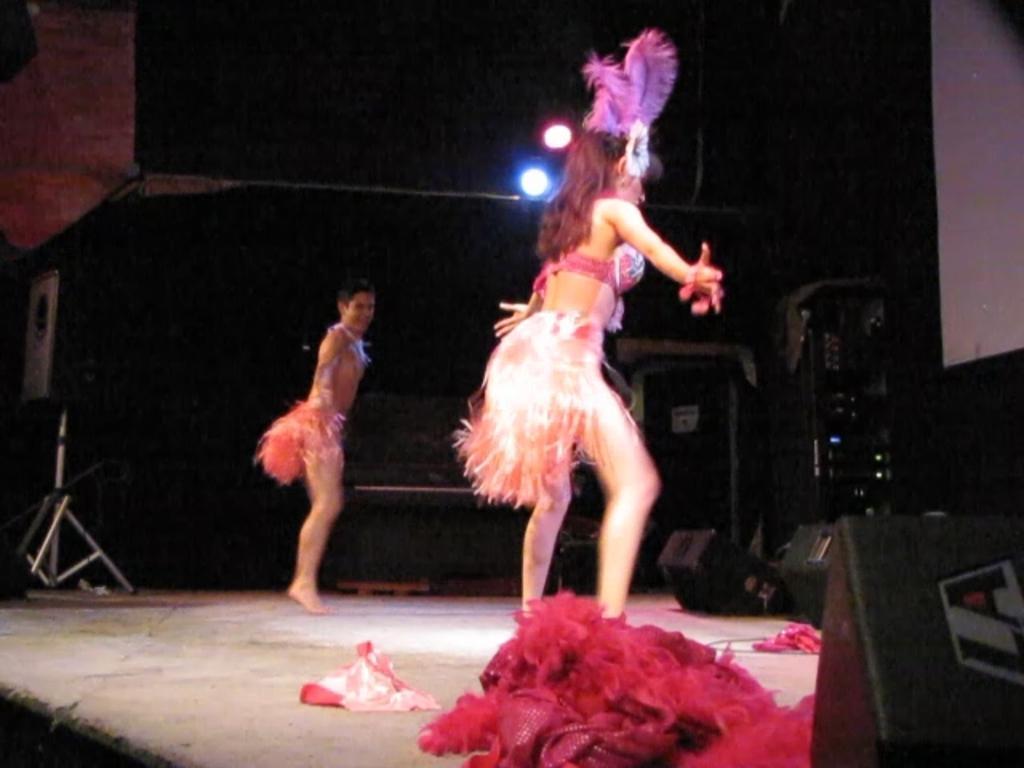In one or two sentences, can you explain what this image depicts? In this image, there are two persons standing and wearing clothes. There is a speaker on the left side of the image. There is an equipment on the right side of the image. 